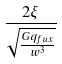<formula> <loc_0><loc_0><loc_500><loc_500>\frac { 2 \xi } { \sqrt { \frac { G q _ { f u x } } { w ^ { 3 } } } }</formula> 